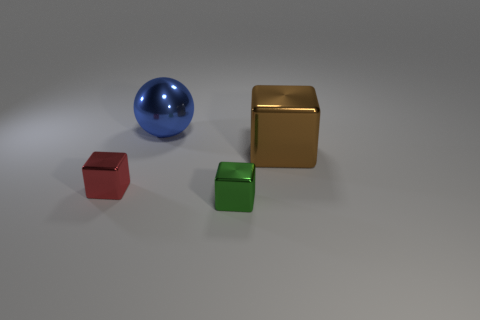Add 2 large green objects. How many objects exist? 6 Subtract all blocks. How many objects are left? 1 Subtract 0 red spheres. How many objects are left? 4 Subtract all large shiny objects. Subtract all big things. How many objects are left? 0 Add 4 big things. How many big things are left? 6 Add 2 tiny objects. How many tiny objects exist? 4 